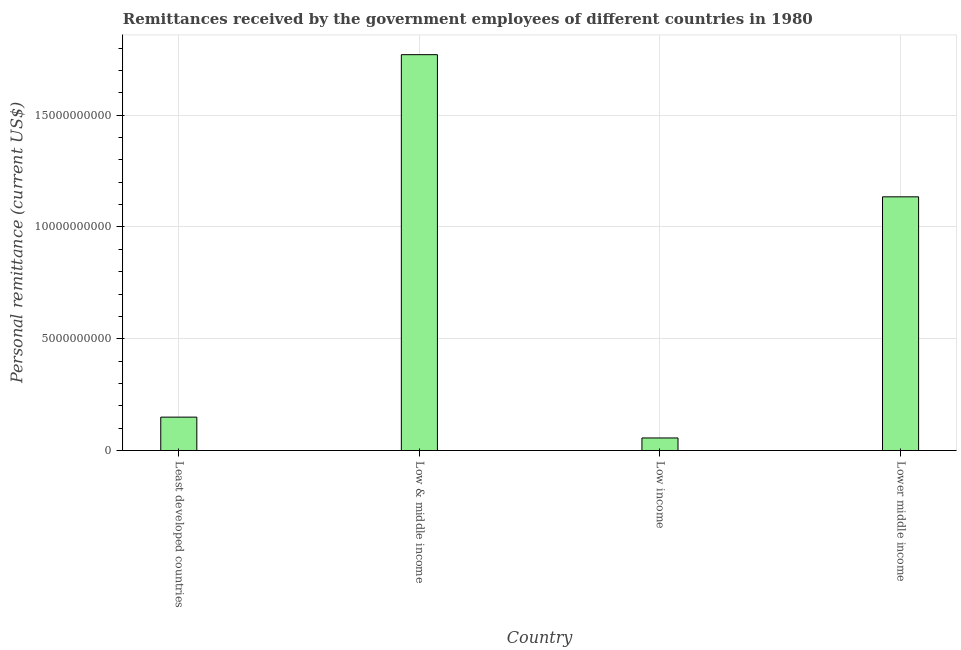What is the title of the graph?
Keep it short and to the point. Remittances received by the government employees of different countries in 1980. What is the label or title of the Y-axis?
Provide a short and direct response. Personal remittance (current US$). What is the personal remittances in Low & middle income?
Your response must be concise. 1.77e+1. Across all countries, what is the maximum personal remittances?
Your answer should be compact. 1.77e+1. Across all countries, what is the minimum personal remittances?
Provide a succinct answer. 5.60e+08. What is the sum of the personal remittances?
Your answer should be very brief. 3.11e+1. What is the difference between the personal remittances in Low & middle income and Lower middle income?
Give a very brief answer. 6.36e+09. What is the average personal remittances per country?
Provide a succinct answer. 7.78e+09. What is the median personal remittances?
Keep it short and to the point. 6.42e+09. In how many countries, is the personal remittances greater than 16000000000 US$?
Your response must be concise. 1. What is the ratio of the personal remittances in Low & middle income to that in Lower middle income?
Offer a terse response. 1.56. What is the difference between the highest and the second highest personal remittances?
Your answer should be compact. 6.36e+09. What is the difference between the highest and the lowest personal remittances?
Your response must be concise. 1.71e+1. How many countries are there in the graph?
Your response must be concise. 4. What is the difference between two consecutive major ticks on the Y-axis?
Keep it short and to the point. 5.00e+09. Are the values on the major ticks of Y-axis written in scientific E-notation?
Offer a terse response. No. What is the Personal remittance (current US$) in Least developed countries?
Keep it short and to the point. 1.49e+09. What is the Personal remittance (current US$) of Low & middle income?
Your answer should be compact. 1.77e+1. What is the Personal remittance (current US$) in Low income?
Provide a short and direct response. 5.60e+08. What is the Personal remittance (current US$) in Lower middle income?
Make the answer very short. 1.13e+1. What is the difference between the Personal remittance (current US$) in Least developed countries and Low & middle income?
Your answer should be compact. -1.62e+1. What is the difference between the Personal remittance (current US$) in Least developed countries and Low income?
Ensure brevity in your answer.  9.32e+08. What is the difference between the Personal remittance (current US$) in Least developed countries and Lower middle income?
Give a very brief answer. -9.86e+09. What is the difference between the Personal remittance (current US$) in Low & middle income and Low income?
Ensure brevity in your answer.  1.71e+1. What is the difference between the Personal remittance (current US$) in Low & middle income and Lower middle income?
Give a very brief answer. 6.36e+09. What is the difference between the Personal remittance (current US$) in Low income and Lower middle income?
Offer a very short reply. -1.08e+1. What is the ratio of the Personal remittance (current US$) in Least developed countries to that in Low & middle income?
Keep it short and to the point. 0.08. What is the ratio of the Personal remittance (current US$) in Least developed countries to that in Low income?
Offer a terse response. 2.66. What is the ratio of the Personal remittance (current US$) in Least developed countries to that in Lower middle income?
Make the answer very short. 0.13. What is the ratio of the Personal remittance (current US$) in Low & middle income to that in Low income?
Your answer should be very brief. 31.61. What is the ratio of the Personal remittance (current US$) in Low & middle income to that in Lower middle income?
Offer a very short reply. 1.56. What is the ratio of the Personal remittance (current US$) in Low income to that in Lower middle income?
Your answer should be compact. 0.05. 